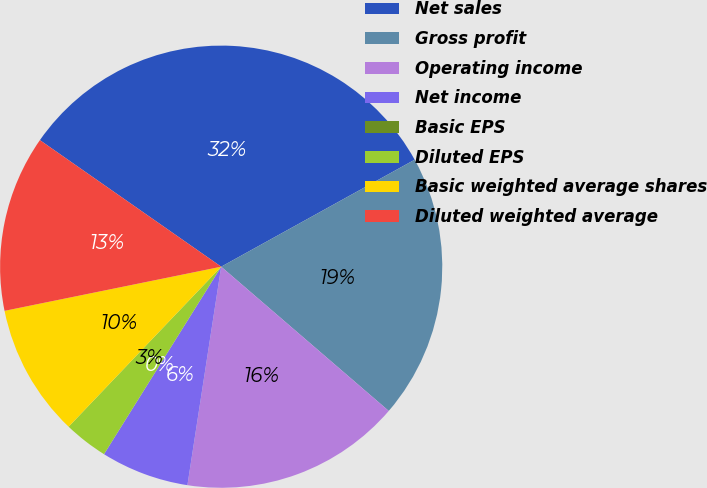Convert chart. <chart><loc_0><loc_0><loc_500><loc_500><pie_chart><fcel>Net sales<fcel>Gross profit<fcel>Operating income<fcel>Net income<fcel>Basic EPS<fcel>Diluted EPS<fcel>Basic weighted average shares<fcel>Diluted weighted average<nl><fcel>32.26%<fcel>19.35%<fcel>16.13%<fcel>6.45%<fcel>0.0%<fcel>3.23%<fcel>9.68%<fcel>12.9%<nl></chart> 